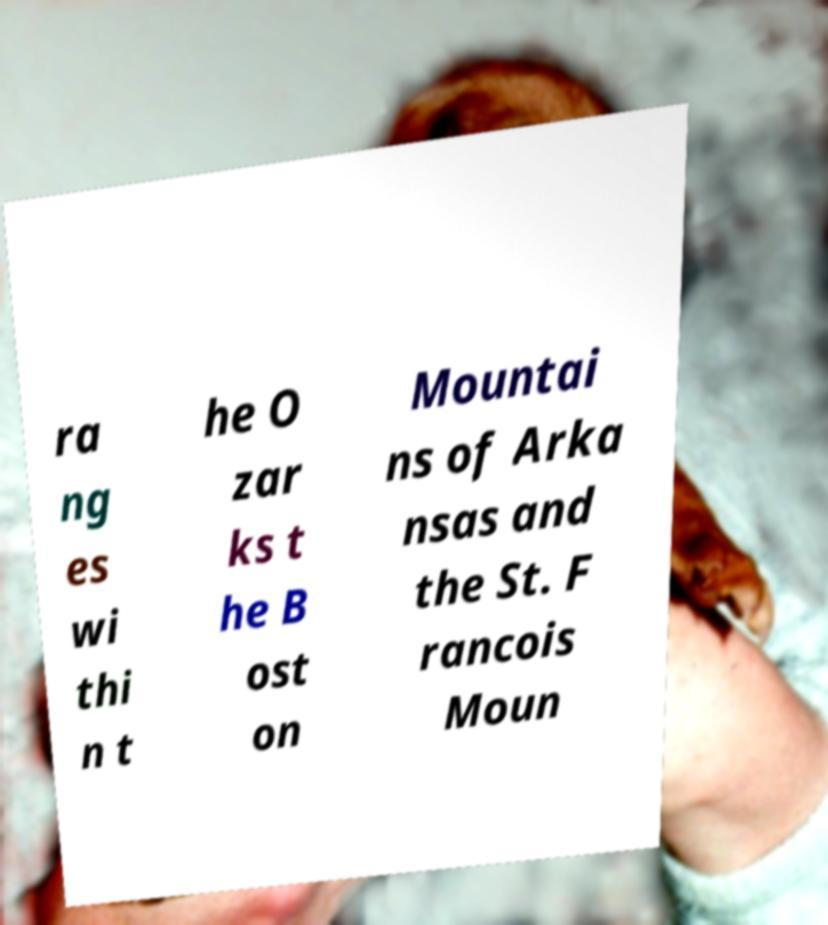Please identify and transcribe the text found in this image. ra ng es wi thi n t he O zar ks t he B ost on Mountai ns of Arka nsas and the St. F rancois Moun 